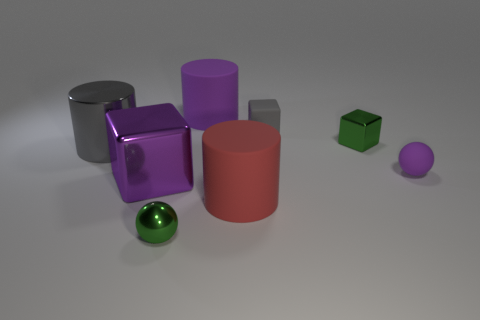There is a green thing in front of the large gray object; is its size the same as the purple rubber thing that is in front of the gray block?
Give a very brief answer. Yes. How big is the green object that is on the left side of the small rubber block?
Ensure brevity in your answer.  Small. How many things are either balls behind the large purple shiny object or balls that are behind the green shiny sphere?
Your response must be concise. 1. Is there any other thing of the same color as the small metal cube?
Ensure brevity in your answer.  Yes. Is the number of purple shiny cubes that are in front of the red rubber cylinder the same as the number of purple things that are to the right of the purple matte cylinder?
Keep it short and to the point. No. Are there more matte objects that are in front of the rubber block than big purple rubber cylinders?
Ensure brevity in your answer.  Yes. What number of objects are large matte objects that are behind the purple ball or yellow metallic objects?
Make the answer very short. 1. How many red blocks have the same material as the big purple cube?
Your answer should be compact. 0. The tiny thing that is the same color as the shiny sphere is what shape?
Make the answer very short. Cube. Are there any other objects of the same shape as the purple metallic thing?
Provide a succinct answer. Yes. 